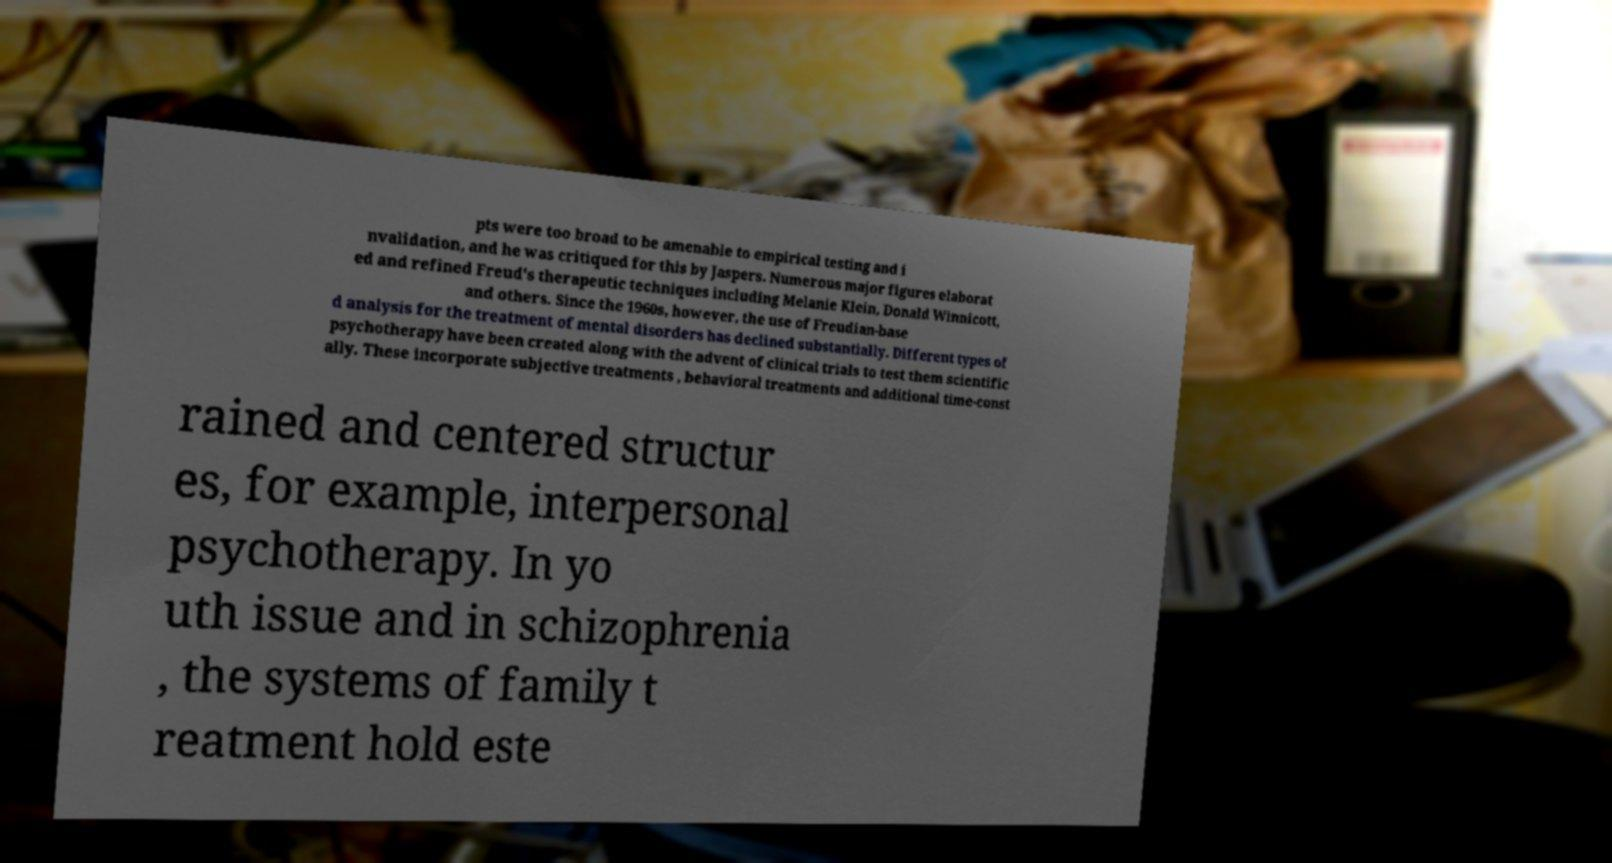There's text embedded in this image that I need extracted. Can you transcribe it verbatim? pts were too broad to be amenable to empirical testing and i nvalidation, and he was critiqued for this by Jaspers. Numerous major figures elaborat ed and refined Freud's therapeutic techniques including Melanie Klein, Donald Winnicott, and others. Since the 1960s, however, the use of Freudian-base d analysis for the treatment of mental disorders has declined substantially. Different types of psychotherapy have been created along with the advent of clinical trials to test them scientific ally. These incorporate subjective treatments , behavioral treatments and additional time-const rained and centered structur es, for example, interpersonal psychotherapy. In yo uth issue and in schizophrenia , the systems of family t reatment hold este 